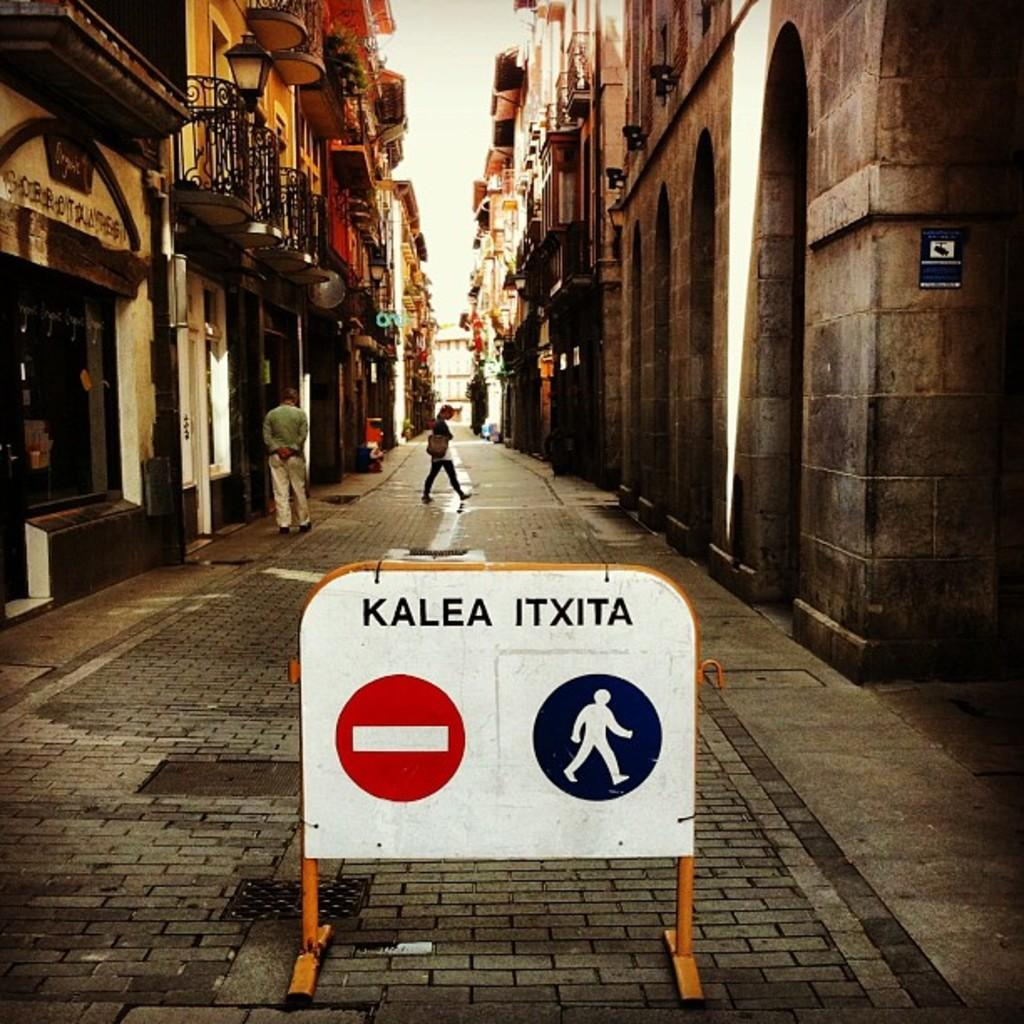<image>
Provide a brief description of the given image. A stop and walk sign, stop is kalea and walk is itxita 